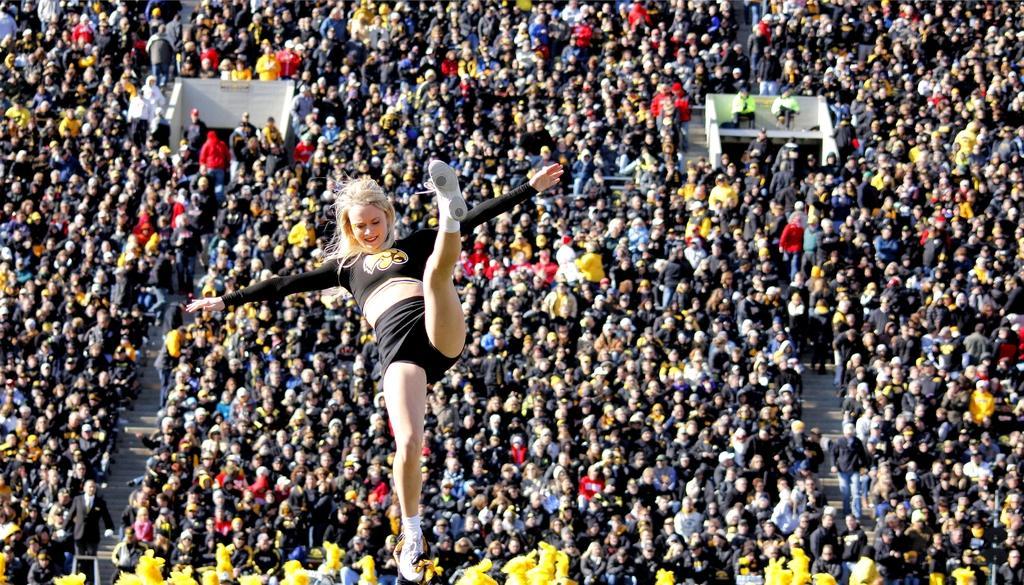How would you summarize this image in a sentence or two? In the middle of the image there is a woman wearing black color dress and jumping. At the bottom, I can see a crowd of people looking at this woman. Few people are sitting and few people are standing. 